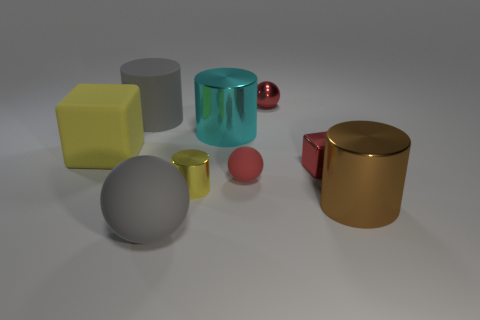Subtract all large cyan metal cylinders. How many cylinders are left? 3 Subtract all red cubes. How many cubes are left? 1 Subtract all balls. How many objects are left? 6 Subtract all cyan spheres. Subtract all gray blocks. How many spheres are left? 3 Subtract all purple cubes. How many red balls are left? 2 Subtract all large gray matte blocks. Subtract all cyan shiny objects. How many objects are left? 8 Add 7 red metallic balls. How many red metallic balls are left? 8 Add 6 large cyan metal cylinders. How many large cyan metal cylinders exist? 7 Add 1 large brown blocks. How many objects exist? 10 Subtract 0 brown blocks. How many objects are left? 9 